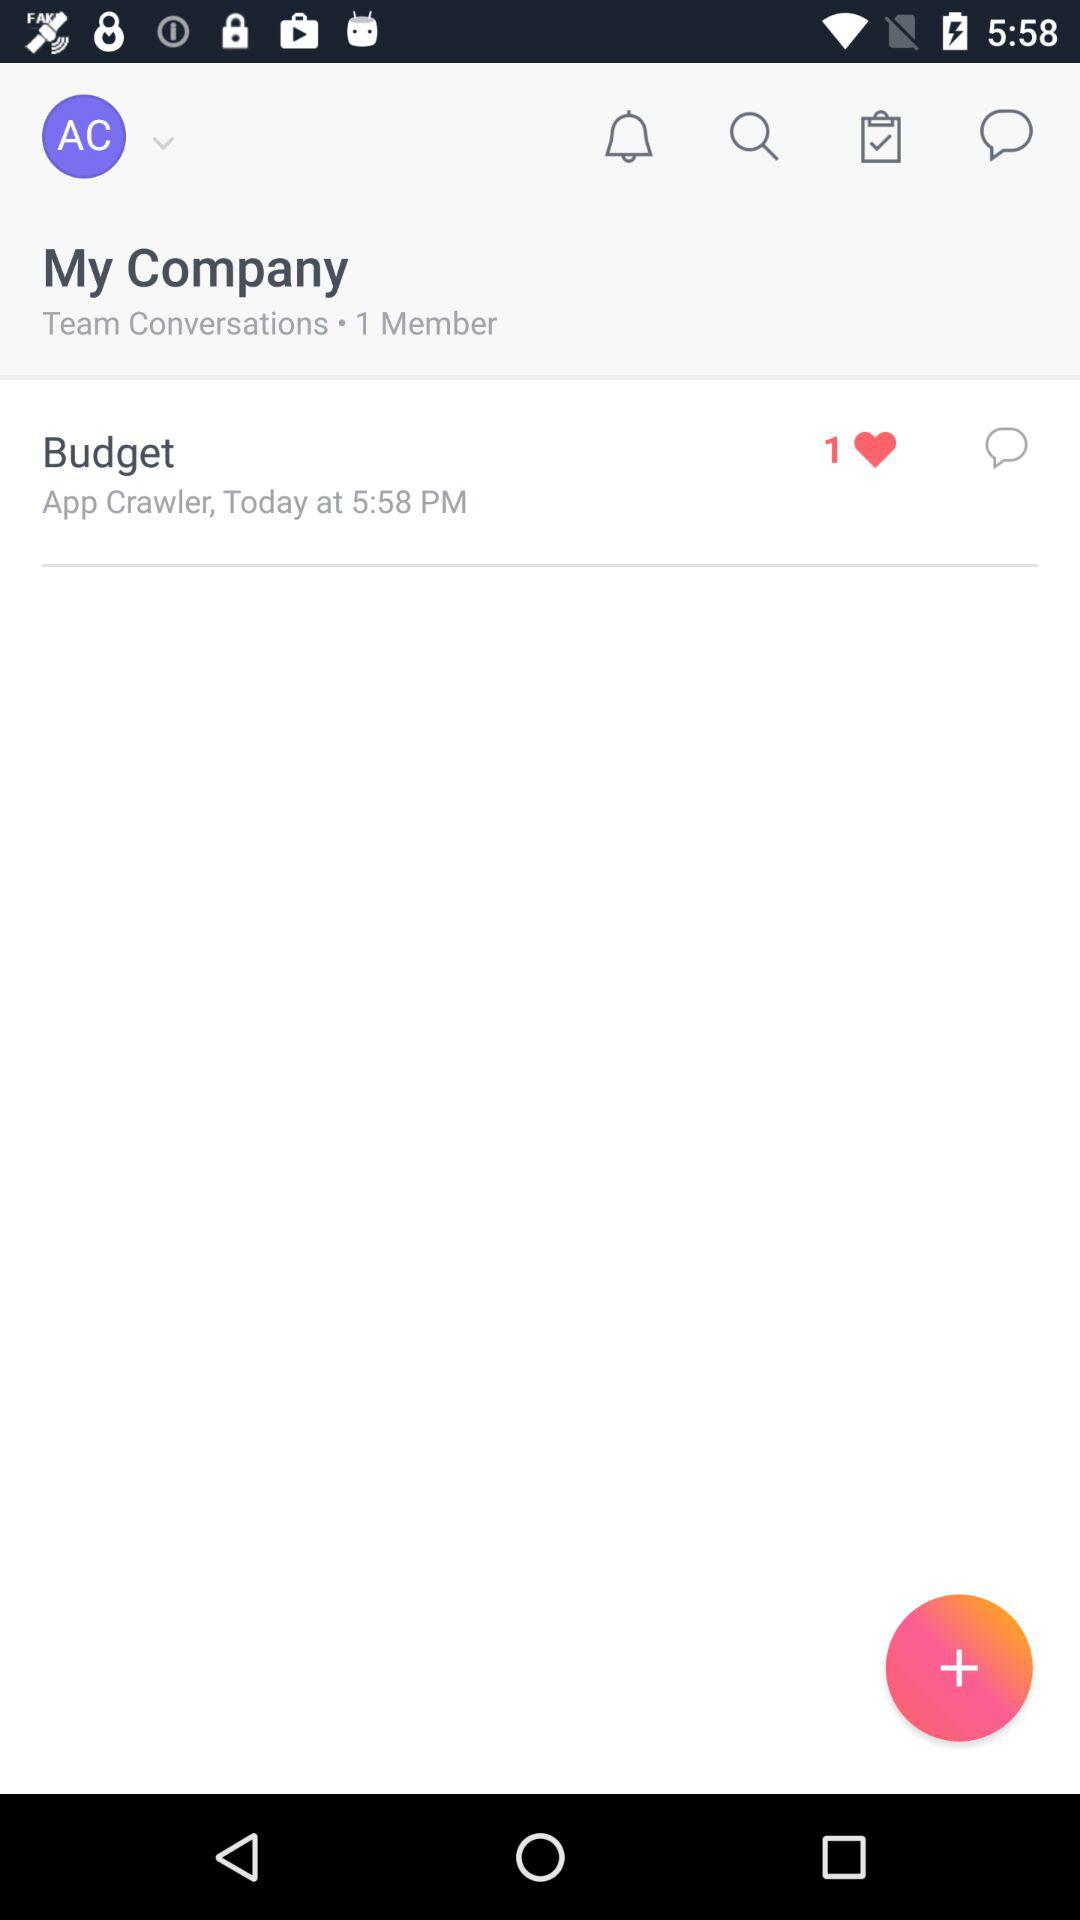How many new notifications are there?
When the provided information is insufficient, respond with <no answer>. <no answer> 